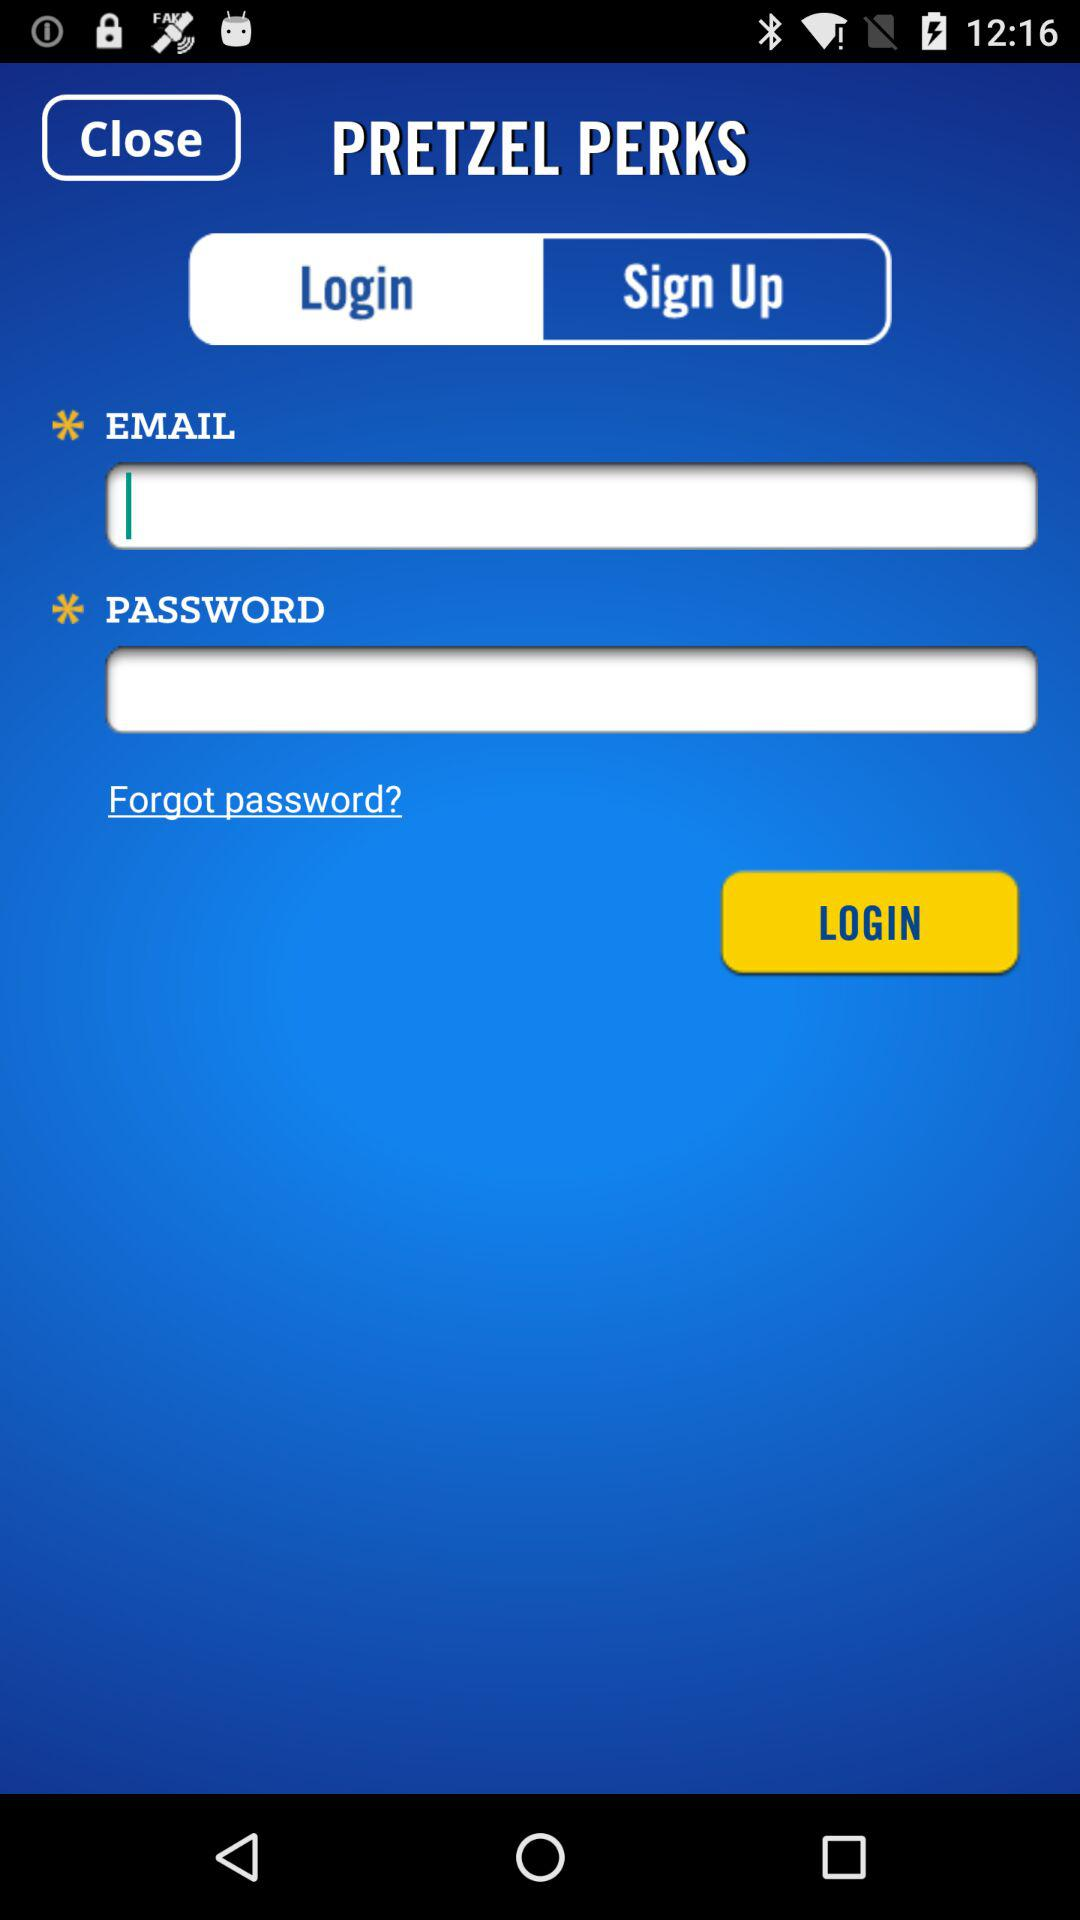What is the name of the application? The name of the application is "PRETZEL PERKS". 